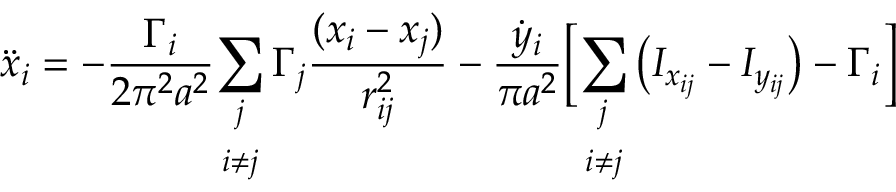<formula> <loc_0><loc_0><loc_500><loc_500>\ddot { x } _ { i } = - \frac { \Gamma _ { i } } { 2 \pi ^ { 2 } a ^ { 2 } } \underset { i \neq j } { \sum _ { j } } \, \Gamma _ { j } \frac { ( x _ { i } - x _ { j } ) } { r _ { i j } ^ { 2 } } - \frac { \dot { y } _ { i } } { \pi a ^ { 2 } } \left [ \underset { i \neq j } { \sum _ { j } } \left ( I _ { x _ { i j } } - I _ { y _ { i j } } \right ) - \Gamma _ { i } \right ]</formula> 